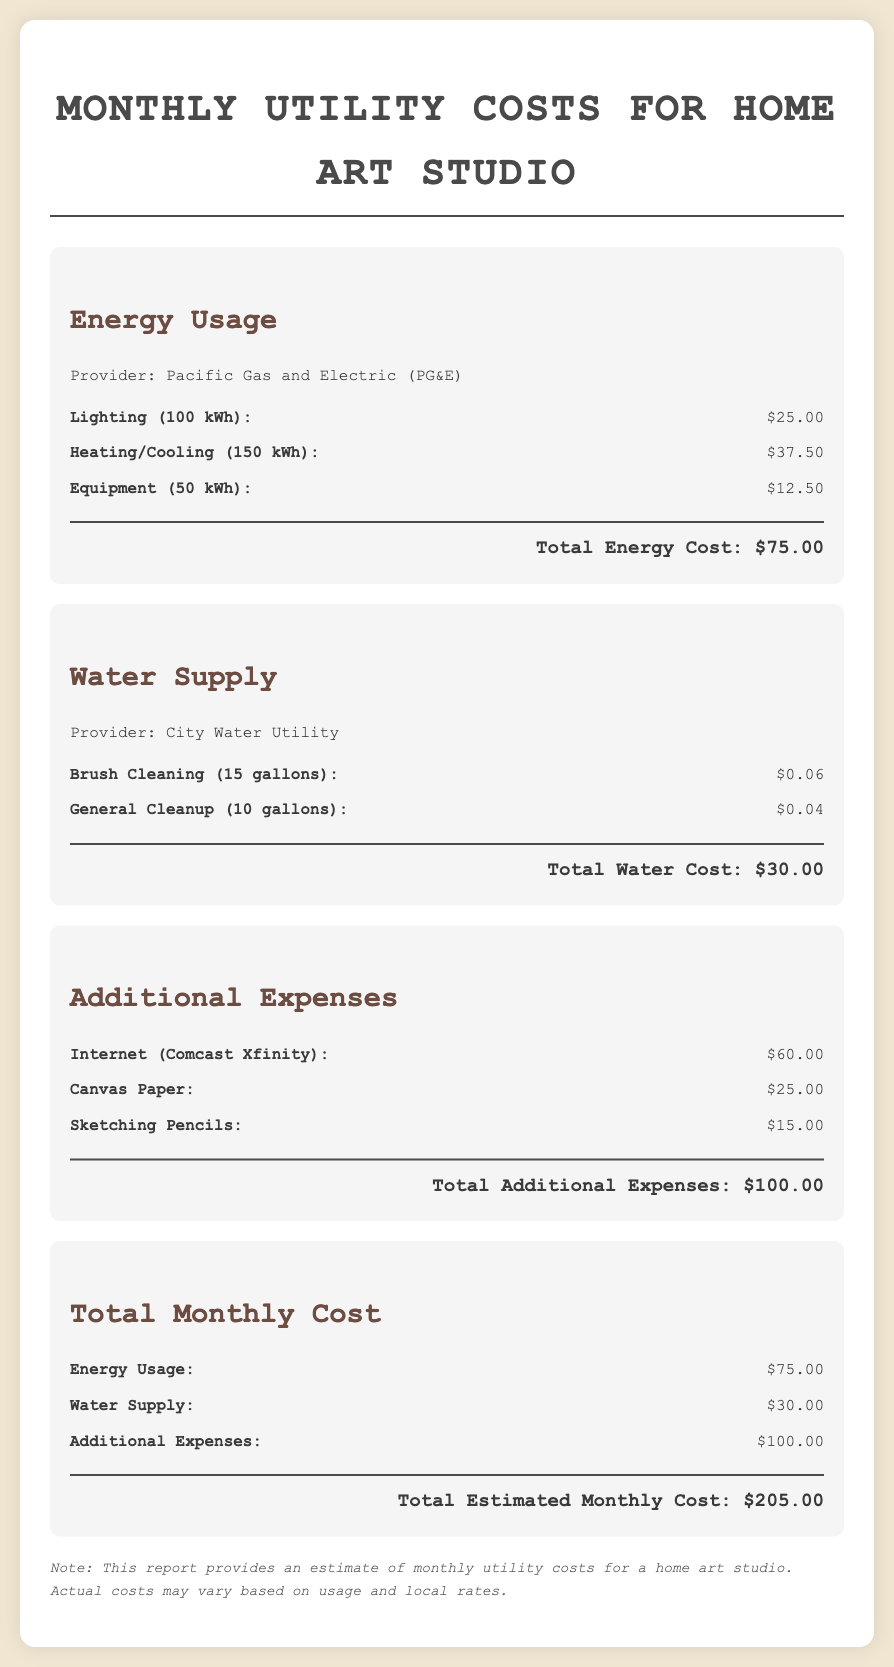What is the total energy cost? The total energy cost is given in the Energy Usage section, which sums up the costs of all energy-related items.
Answer: $75.00 How much is spent on water supply? The total water cost is the sum of the costs listed under the Water Supply section.
Answer: $30.00 What is the cost of sketching pencils? The cost of sketching pencils is listed under Additional Expenses, indicating the price for these materials.
Answer: $15.00 Who provides the energy for the studio? The document specifies the energy provider for the home studio, which is mentioned in the Energy Usage section.
Answer: Pacific Gas and Electric (PG&E) What is the total estimated monthly cost? The total estimated monthly cost is calculated by summing the costs from all sections of the report.
Answer: $205.00 How many gallons are used for brush cleaning? The document states the amount of water used for brush cleaning in the Water Supply section.
Answer: 15 gallons What expense is associated with Internet service? The document lists a specific expense for Internet services, which is detailed under Additional Expenses.
Answer: $60.00 What is the total cost of canvas paper? The document includes the cost for canvas paper in the Additional Expenses section clearly listed.
Answer: $25.00 What type of document is this? The structured nature of the content and focus on utility costs indicate that this is a specific type of report.
Answer: Financial report 